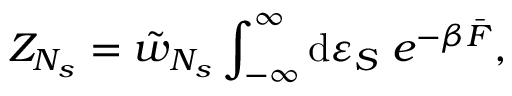Convert formula to latex. <formula><loc_0><loc_0><loc_500><loc_500>Z _ { N _ { s } } = \tilde { w } _ { N _ { s } } \int _ { - \infty } ^ { \infty } { d \varepsilon _ { S } \, e ^ { - \beta \bar { F } } } ,</formula> 